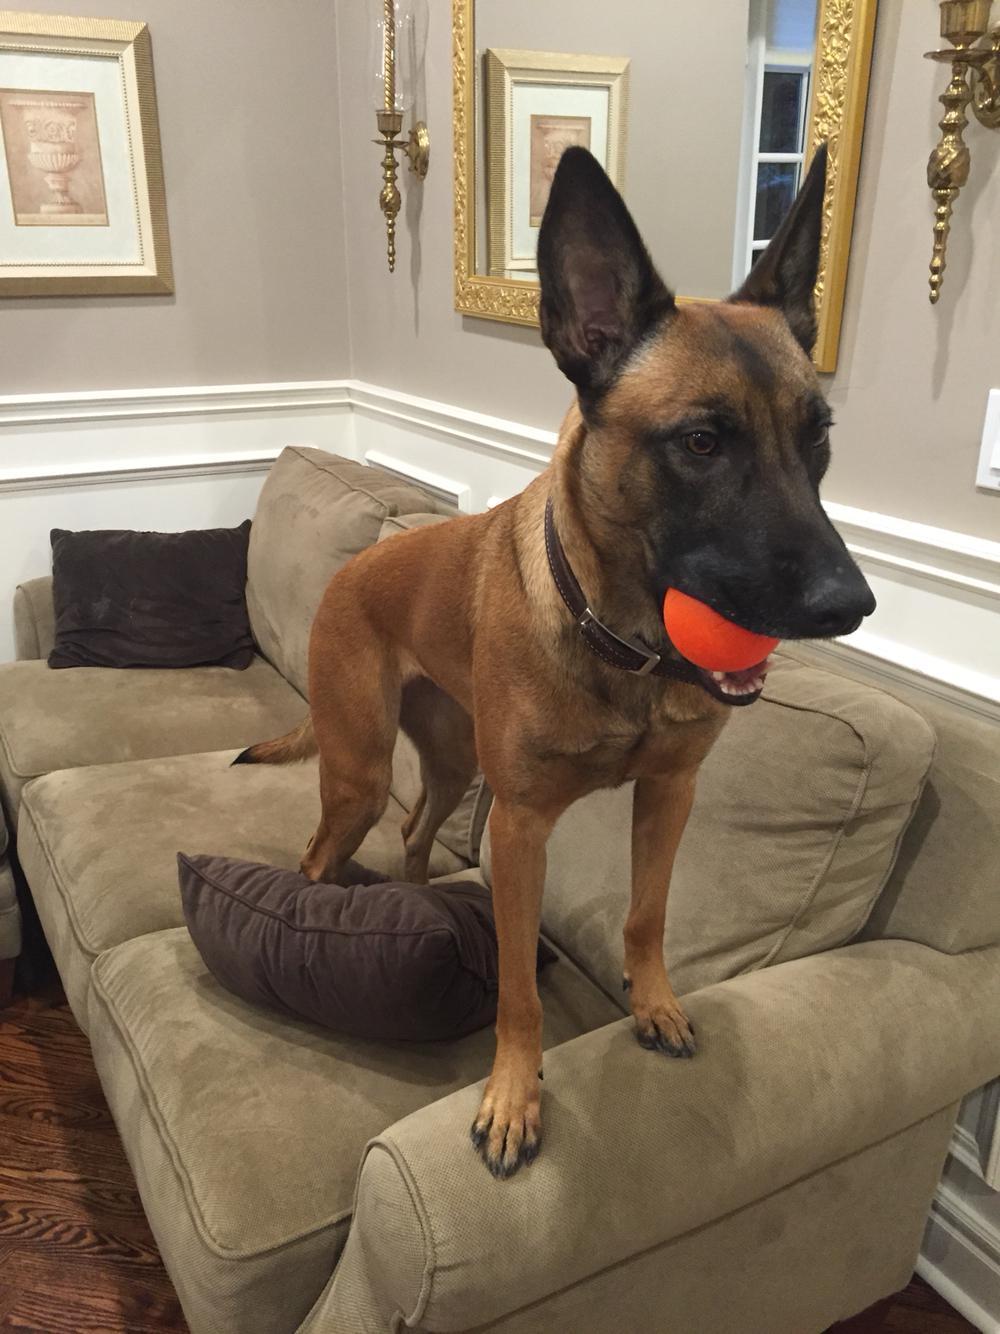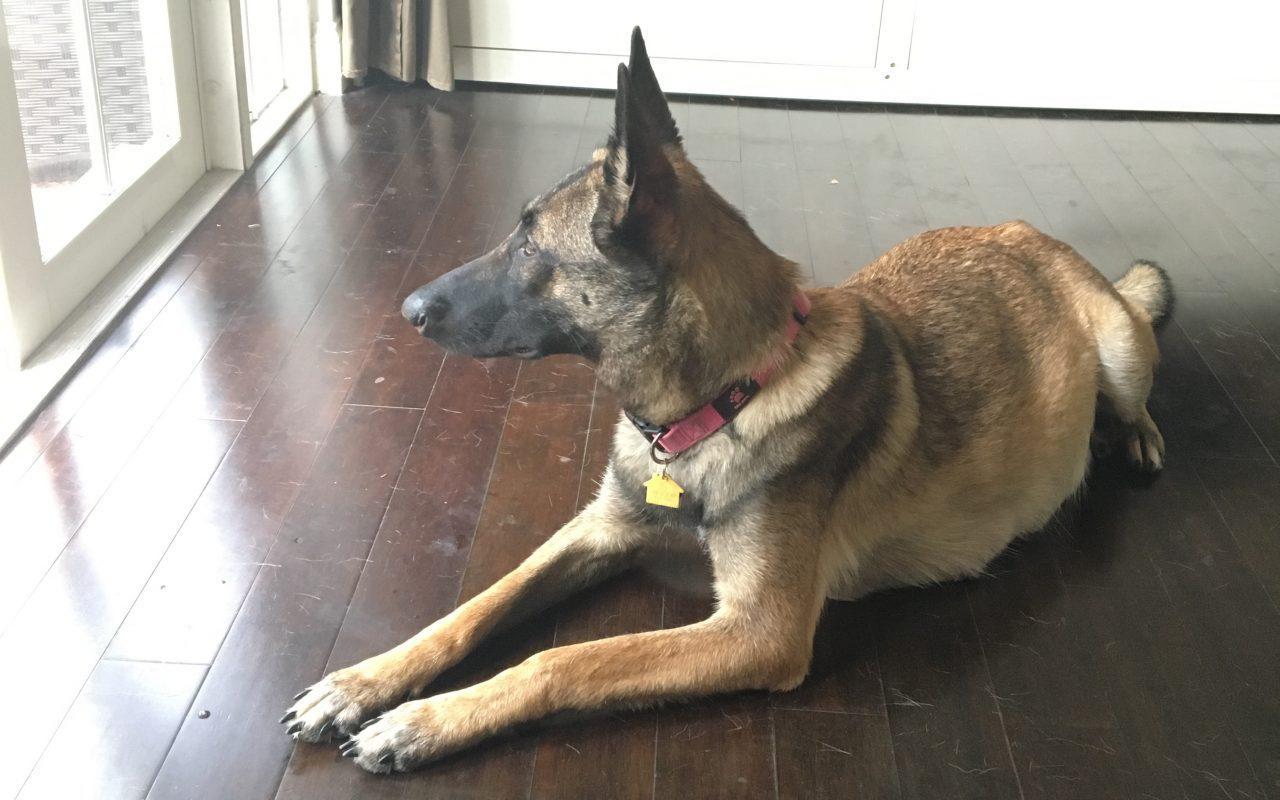The first image is the image on the left, the second image is the image on the right. Examine the images to the left and right. Is the description "One dog is lying down." accurate? Answer yes or no. Yes. The first image is the image on the left, the second image is the image on the right. Examine the images to the left and right. Is the description "The right image contains one german shepherd on pavement, looking upward with his head cocked rightward." accurate? Answer yes or no. No. 